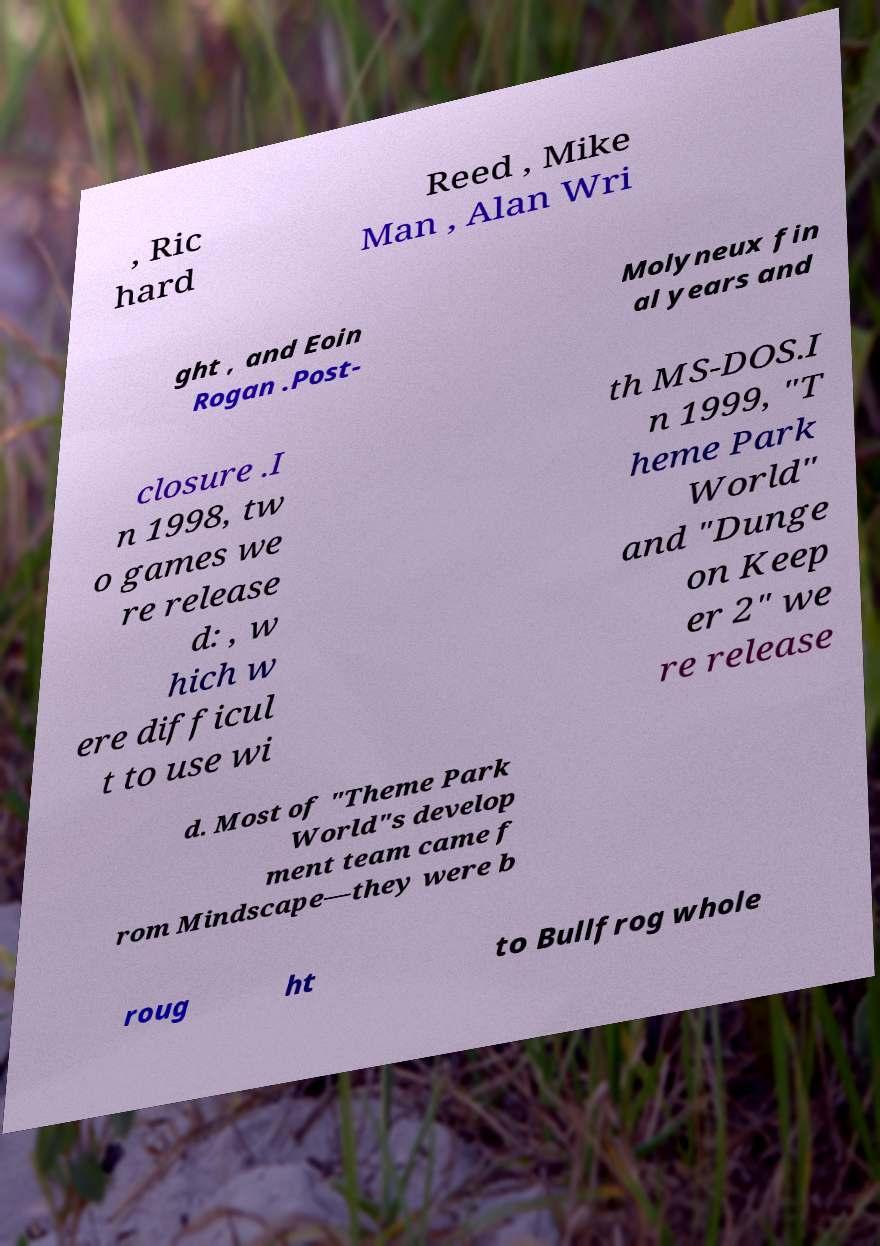Please read and relay the text visible in this image. What does it say? , Ric hard Reed , Mike Man , Alan Wri ght , and Eoin Rogan .Post- Molyneux fin al years and closure .I n 1998, tw o games we re release d: , w hich w ere difficul t to use wi th MS-DOS.I n 1999, "T heme Park World" and "Dunge on Keep er 2" we re release d. Most of "Theme Park World"s develop ment team came f rom Mindscape—they were b roug ht to Bullfrog whole 